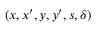<formula> <loc_0><loc_0><loc_500><loc_500>( x , x ^ { \prime } , y , y ^ { \prime } , s , \delta )</formula> 